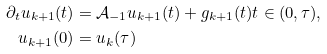Convert formula to latex. <formula><loc_0><loc_0><loc_500><loc_500>\partial _ { t } u _ { k + 1 } ( t ) & = \mathcal { A } _ { - 1 } u _ { k + 1 } ( t ) + g _ { k + 1 } ( t ) t \in ( 0 , \tau ) , \\ u _ { k + 1 } ( 0 ) & = u _ { k } ( \tau )</formula> 